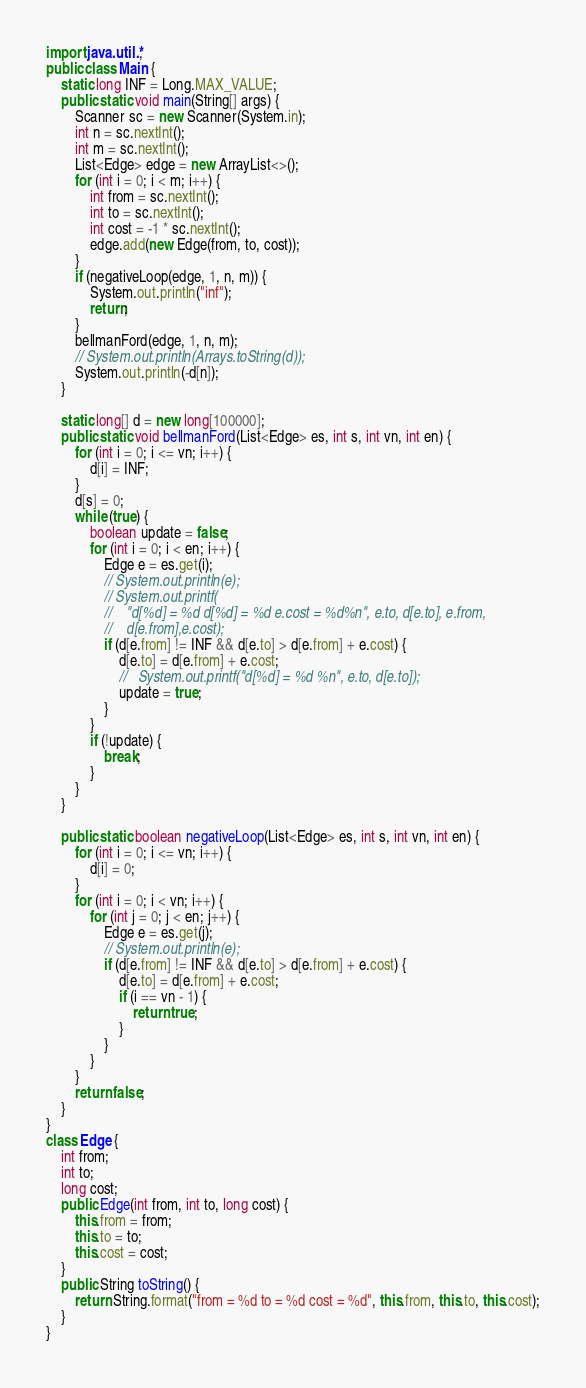<code> <loc_0><loc_0><loc_500><loc_500><_Java_>import java.util.*;
public class Main {
    static long INF = Long.MAX_VALUE;
    public static void main(String[] args) {
        Scanner sc = new Scanner(System.in);
        int n = sc.nextInt();
        int m = sc.nextInt();
        List<Edge> edge = new ArrayList<>();
        for (int i = 0; i < m; i++) {
            int from = sc.nextInt();
            int to = sc.nextInt();
            int cost = -1 * sc.nextInt();
            edge.add(new Edge(from, to, cost));
        }
        if (negativeLoop(edge, 1, n, m)) {
            System.out.println("inf");
            return;
        }
        bellmanFord(edge, 1, n, m);
        // System.out.println(Arrays.toString(d));
        System.out.println(-d[n]);
    }

    static long[] d = new long[100000];
    public static void bellmanFord(List<Edge> es, int s, int vn, int en) {
        for (int i = 0; i <= vn; i++) {
            d[i] = INF;
        }
        d[s] = 0;
        while (true) {
            boolean update = false;
            for (int i = 0; i < en; i++) {
                Edge e = es.get(i);
                // System.out.println(e);
                // System.out.printf(
                //    "d[%d] = %d d[%d] = %d e.cost = %d%n", e.to, d[e.to], e.from,
                //    d[e.from],e.cost);
                if (d[e.from] != INF && d[e.to] > d[e.from] + e.cost) {
                    d[e.to] = d[e.from] + e.cost;
                    //   System.out.printf("d[%d] = %d %n", e.to, d[e.to]);
                    update = true;
                }
            }
            if (!update) {
                break;
            }
        }
    }

    public static boolean negativeLoop(List<Edge> es, int s, int vn, int en) {
        for (int i = 0; i <= vn; i++) {
            d[i] = 0;
        }
        for (int i = 0; i < vn; i++) {
            for (int j = 0; j < en; j++) {
                Edge e = es.get(j);
                // System.out.println(e);
                if (d[e.from] != INF && d[e.to] > d[e.from] + e.cost) {
                    d[e.to] = d[e.from] + e.cost;
                    if (i == vn - 1) {
                        return true;
                    }
                }
            }
        }
        return false;
    }
}
class Edge {
    int from;
    int to;
    long cost;
    public Edge(int from, int to, long cost) {
        this.from = from;
        this.to = to;
        this.cost = cost;
    }
    public String toString() {
        return String.format("from = %d to = %d cost = %d", this.from, this.to, this.cost);
    }
}
</code> 